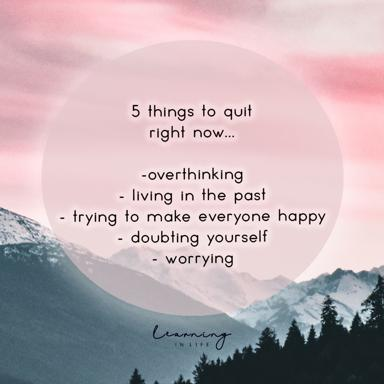How might the choice of typography influence the message conveyed by this image? The use of a gentle, cursive typography in the image softens the overall feel and aligns with the soothing qualities of the nature scene in the background. It gives the text a personal, handwritten quality that may make the advice feel more intimate and caring, thus enhancing the emotional impact of the message. 